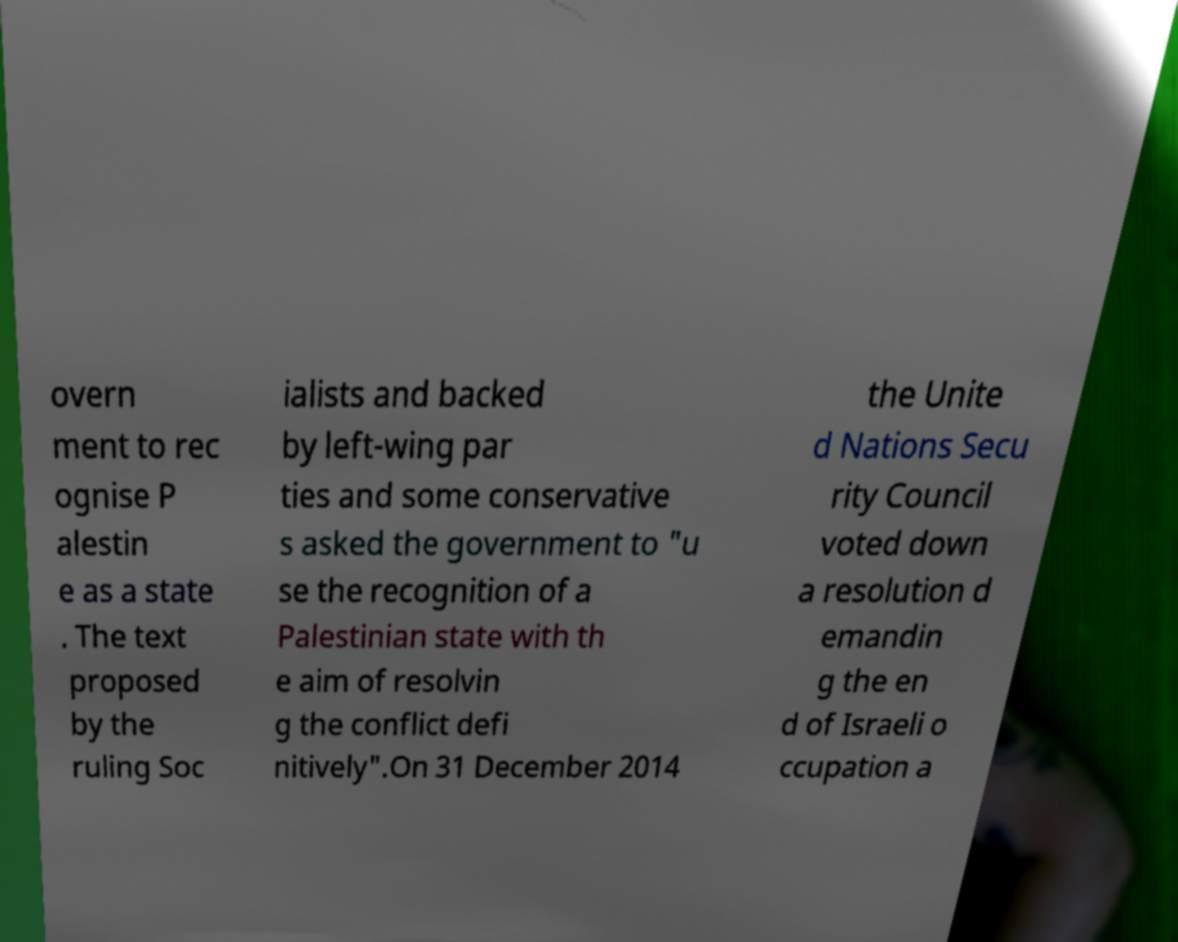Could you extract and type out the text from this image? overn ment to rec ognise P alestin e as a state . The text proposed by the ruling Soc ialists and backed by left-wing par ties and some conservative s asked the government to "u se the recognition of a Palestinian state with th e aim of resolvin g the conflict defi nitively".On 31 December 2014 the Unite d Nations Secu rity Council voted down a resolution d emandin g the en d of Israeli o ccupation a 